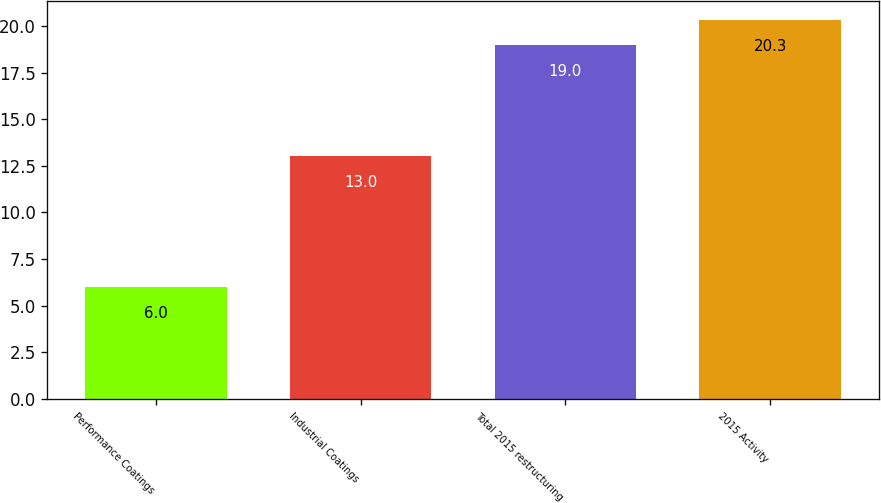<chart> <loc_0><loc_0><loc_500><loc_500><bar_chart><fcel>Performance Coatings<fcel>Industrial Coatings<fcel>Total 2015 restructuring<fcel>2015 Activity<nl><fcel>6<fcel>13<fcel>19<fcel>20.3<nl></chart> 